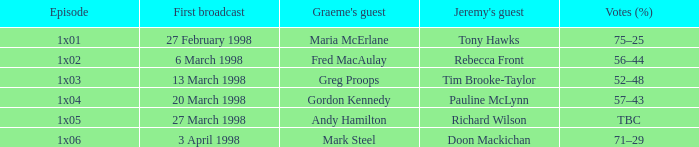What is First Broadcast, when Jeremy's Guest is "Tim Brooke-Taylor"? 13 March 1998. 